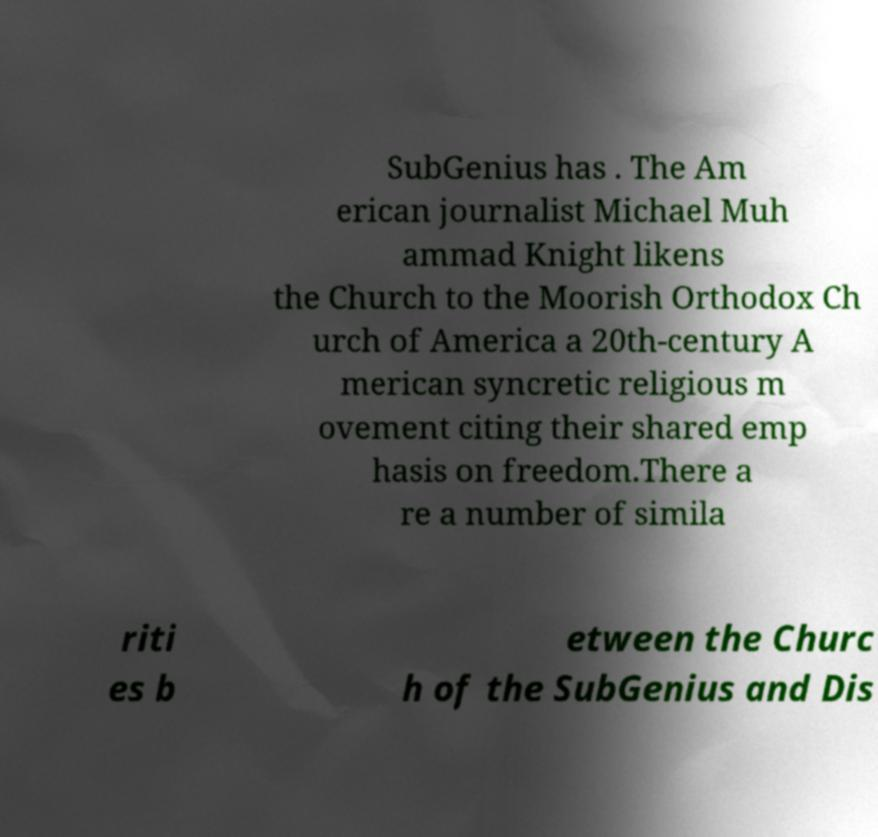There's text embedded in this image that I need extracted. Can you transcribe it verbatim? SubGenius has . The Am erican journalist Michael Muh ammad Knight likens the Church to the Moorish Orthodox Ch urch of America a 20th-century A merican syncretic religious m ovement citing their shared emp hasis on freedom.There a re a number of simila riti es b etween the Churc h of the SubGenius and Dis 